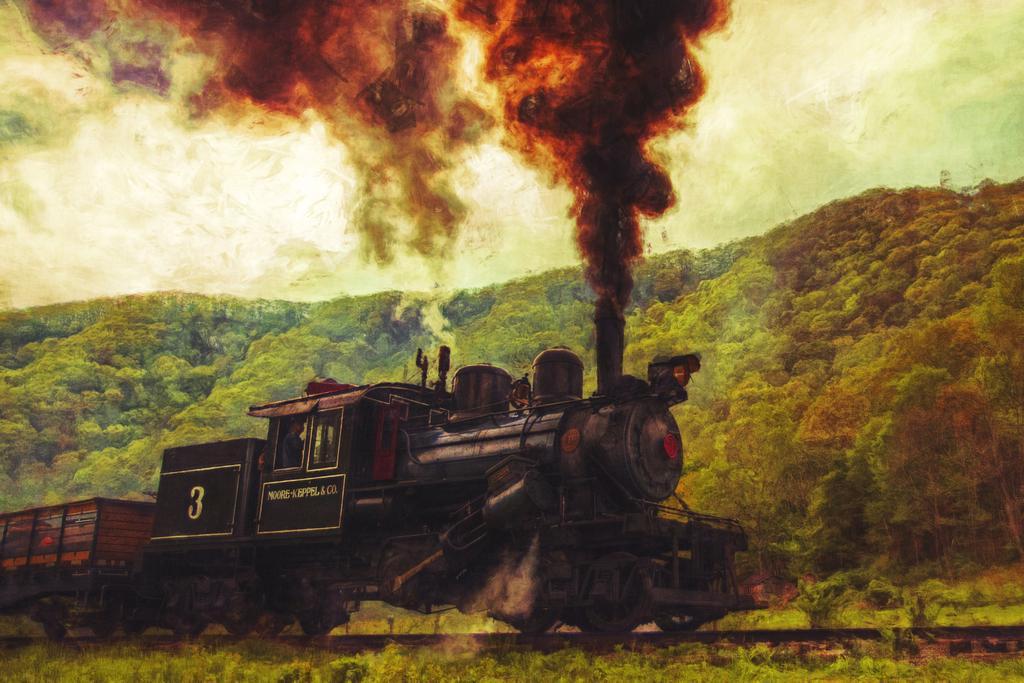Describe this image in one or two sentences. In this image I can see a train on the railway-track which is in black and brown color. Back I can see trees. I can see a sky. 